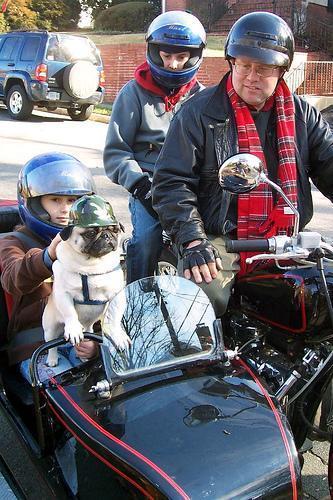How many dogs are pictured here?
Give a very brief answer. 1. How many people are in the picture?
Give a very brief answer. 3. How many people are wearing helmets?
Give a very brief answer. 3. How many people can you see?
Give a very brief answer. 3. How many trucks are in the picture?
Give a very brief answer. 1. How many dogs are in the picture?
Give a very brief answer. 1. How many horses are there in this picture?
Give a very brief answer. 0. 